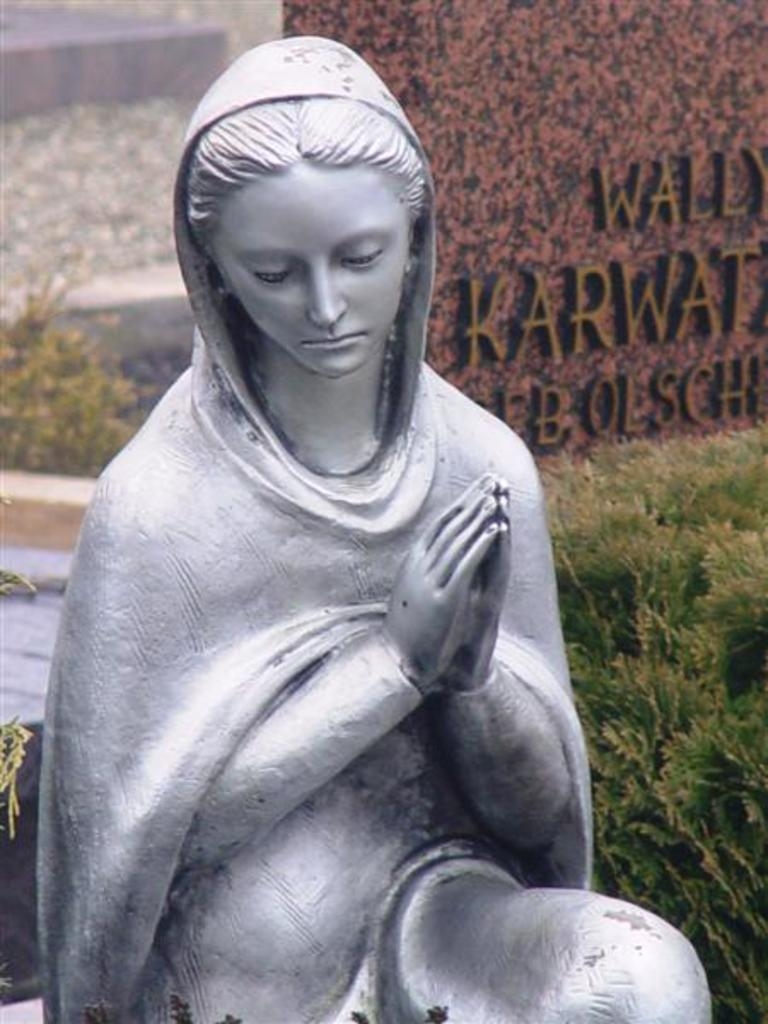What is the main subject in the foreground of the image? There is a sculpture of a woman in the foreground. What can be seen on the right side of the image? There are plants and a wall with text on it on the right side of the image. What is located on the left side of the image? There is a wooden object on the left side of the image. Can you describe the background of the image? The background is not clear, so it is difficult to provide specific details about it. How many times does the number act in the image? There is no number or act present in the image, so this question cannot be answered. 